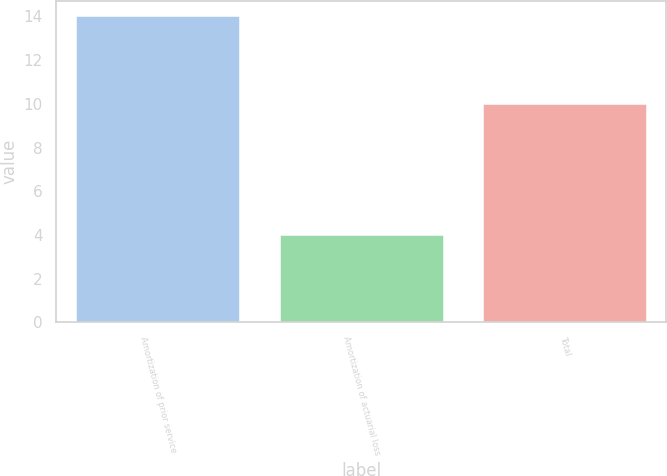Convert chart. <chart><loc_0><loc_0><loc_500><loc_500><bar_chart><fcel>Amortization of prior service<fcel>Amortization of actuarial loss<fcel>Total<nl><fcel>14<fcel>4<fcel>10<nl></chart> 